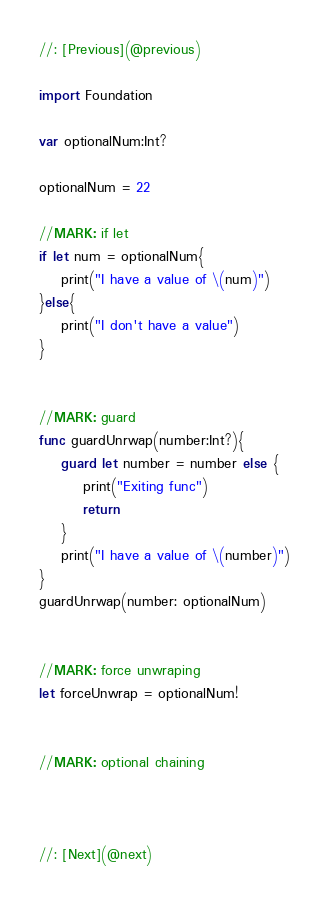<code> <loc_0><loc_0><loc_500><loc_500><_Swift_>//: [Previous](@previous)

import Foundation

var optionalNum:Int?

optionalNum = 22

//MARK: if let
if let num = optionalNum{
    print("I have a value of \(num)")
}else{
    print("I don't have a value")
}


//MARK: guard
func guardUnrwap(number:Int?){
    guard let number = number else {
        print("Exiting func")
        return
    }
    print("I have a value of \(number)")
}
guardUnrwap(number: optionalNum)


//MARK: force unwraping
let forceUnwrap = optionalNum!


//MARK: optional chaining



//: [Next](@next)
</code> 